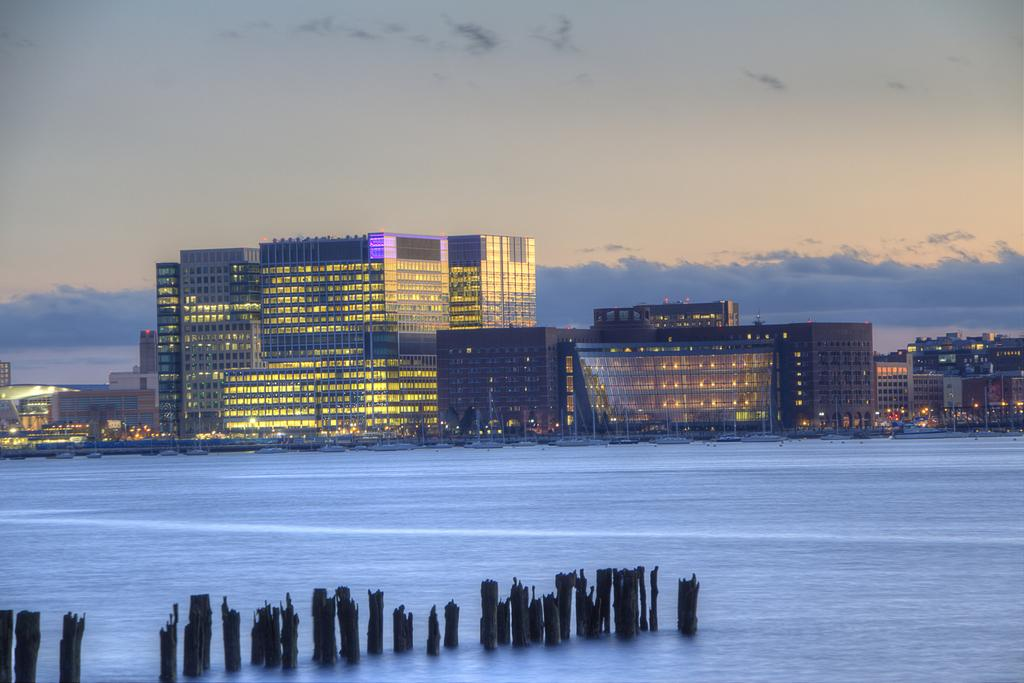What type of natural feature is at the bottom of the image? There is a river at the bottom of the image. What objects can be seen in the image besides the river? There are wooden poles in the image. What can be seen in the background of the image? There are buildings, poles, and lights in the background of the image. What is visible at the top of the image? The sky is visible at the top of the image. How many eyes can be seen on the wooden poles in the image? There are no eyes present on the wooden poles in the image. What type of club is located near the river in the image? There is no club present near the river in the image. 